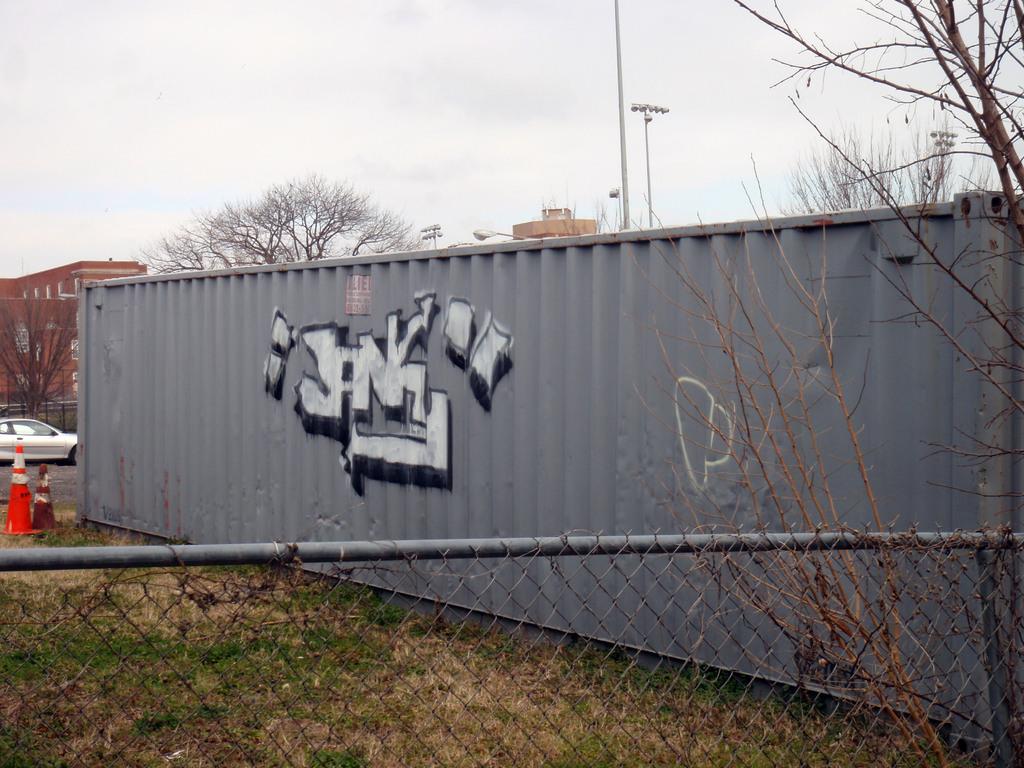What name is on the graffiti?
Give a very brief answer. Janky. What is the color of the container?
Your answer should be compact. Answering does not require reading text in the image. 